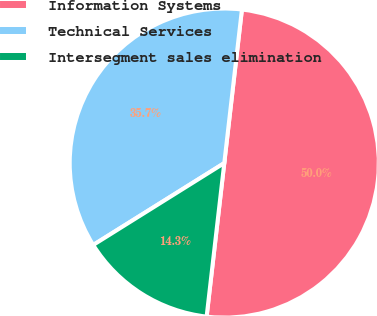<chart> <loc_0><loc_0><loc_500><loc_500><pie_chart><fcel>Information Systems<fcel>Technical Services<fcel>Intersegment sales elimination<nl><fcel>50.0%<fcel>35.71%<fcel>14.29%<nl></chart> 